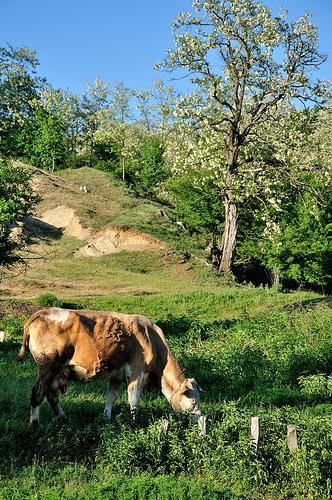State the central figure of the image and its engagement. The key subject is a brown and white cow, which is feeding on grass in the field. Identify the primary subject of the image and describe what they are doing. The main subject is a cow with brown and white patches, as it grazes on grass in a field. Write a short sentence describing the main element in the image and its action. A cow with brown and white markings is busy grazing on grass in the field. Furnish a brief description of the central character in the image and their activity. A brown and white cow can be seen as the main subject, consuming grass in an open area. Report the central element of the image and describe its engagement. A cow characterized by its brown and white markings is the core element, actively feeding on grass in the field. Provide a brief description of the primary object in the image and its action. A brown and white cow is grazing on grass in the field with its head down. Mention the dominant entity in the image and its ongoing activity. The brown and white cow is the main focus, eating grass in a field. Express the main focus of the image and its associated activity. The image centers on a brown and white cow busily grazing on grass in the field. Point out the principal object in the photograph and its current action. The foremost object is a brown and white cow munching on grass in a pasture. Offer a concise summary of the main subject in the image and their activity. The image features a brown and white cow that is grazing on grass in an open field. 